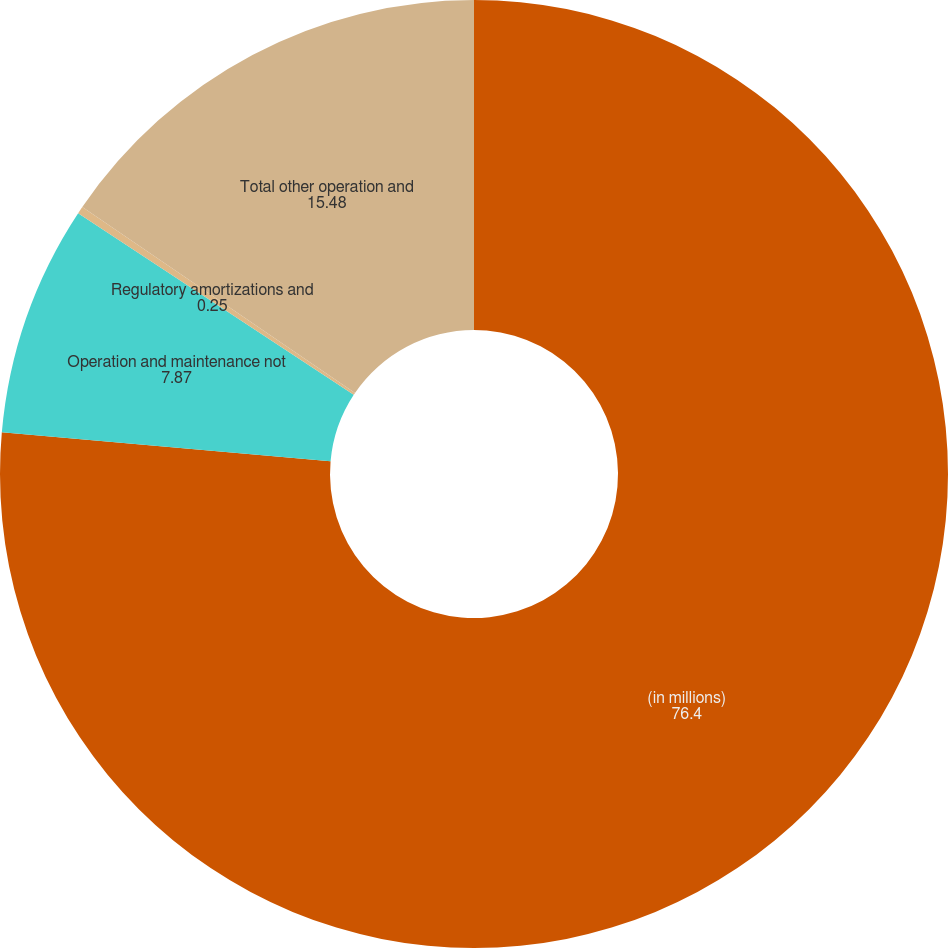<chart> <loc_0><loc_0><loc_500><loc_500><pie_chart><fcel>(in millions)<fcel>Operation and maintenance not<fcel>Regulatory amortizations and<fcel>Total other operation and<nl><fcel>76.4%<fcel>7.87%<fcel>0.25%<fcel>15.48%<nl></chart> 